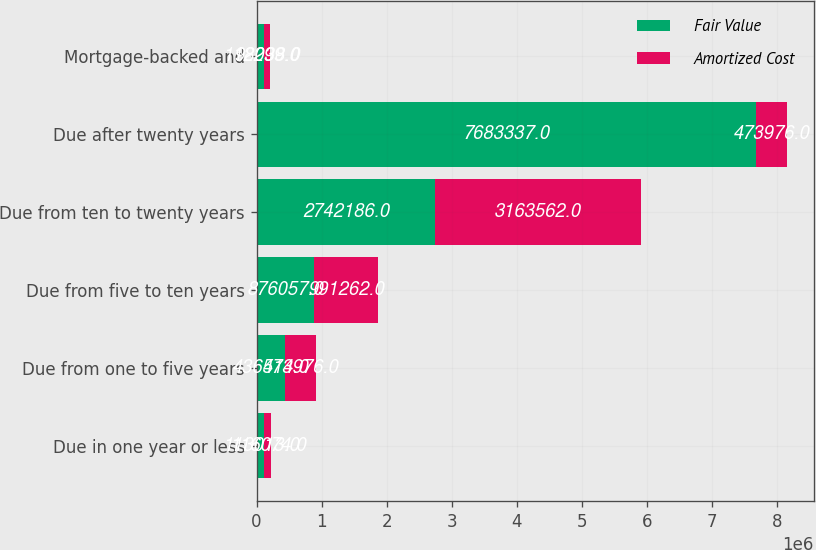<chart> <loc_0><loc_0><loc_500><loc_500><stacked_bar_chart><ecel><fcel>Due in one year or less<fcel>Due from one to five years<fcel>Due from five to ten years<fcel>Due from ten to twenty years<fcel>Due after twenty years<fcel>Mortgage-backed and<nl><fcel>Fair Value<fcel>113013<fcel>436514<fcel>876057<fcel>2.74219e+06<fcel>7.68334e+06<fcel>112299<nl><fcel>Amortized Cost<fcel>116074<fcel>473976<fcel>991262<fcel>3.16356e+06<fcel>473976<fcel>98038<nl></chart> 